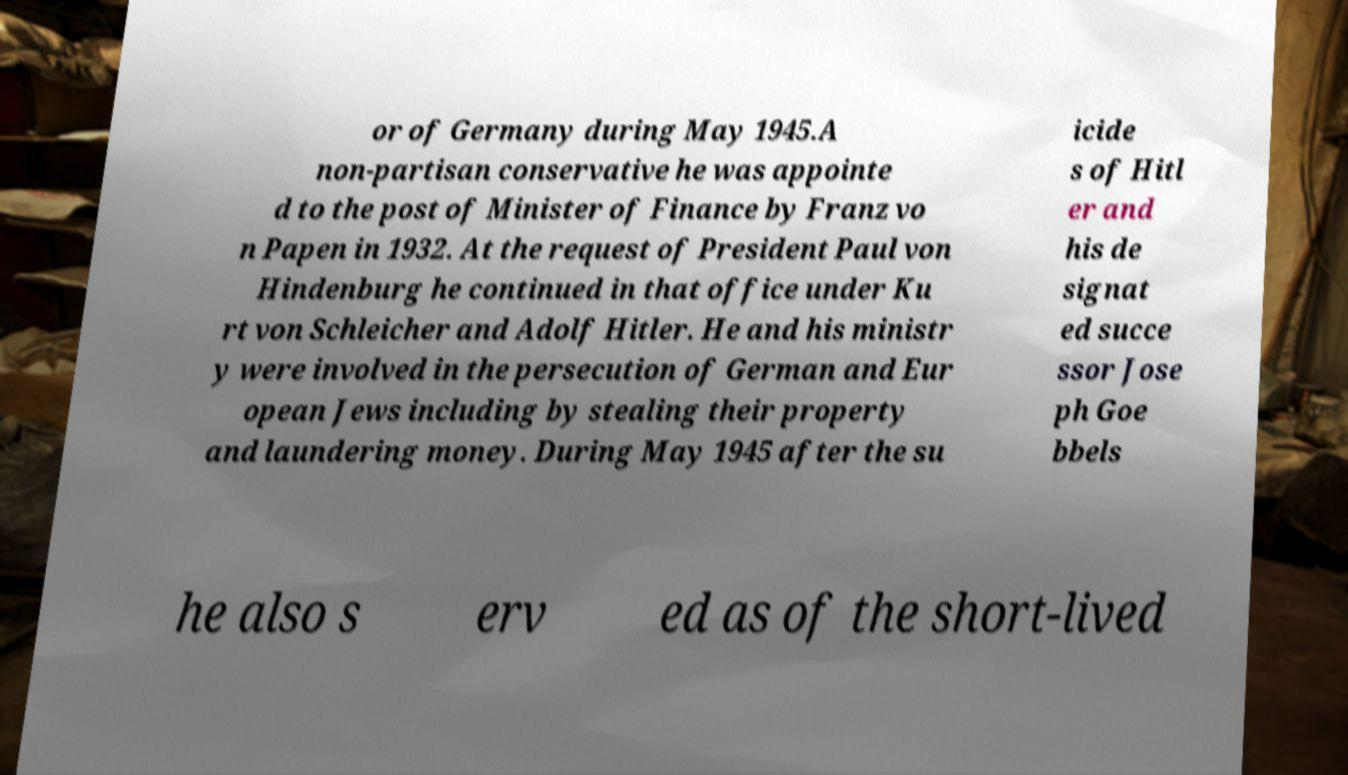There's text embedded in this image that I need extracted. Can you transcribe it verbatim? or of Germany during May 1945.A non-partisan conservative he was appointe d to the post of Minister of Finance by Franz vo n Papen in 1932. At the request of President Paul von Hindenburg he continued in that office under Ku rt von Schleicher and Adolf Hitler. He and his ministr y were involved in the persecution of German and Eur opean Jews including by stealing their property and laundering money. During May 1945 after the su icide s of Hitl er and his de signat ed succe ssor Jose ph Goe bbels he also s erv ed as of the short-lived 